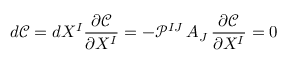<formula> <loc_0><loc_0><loc_500><loc_500>d \mathcal { C } = d X ^ { I } \frac { \partial \mathcal { C } } { \partial X ^ { I } } = - \mathcal { P } ^ { I J } \, A _ { J } \, \frac { \partial \mathcal { C } } { \partial X ^ { I } } = 0</formula> 